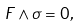Convert formula to latex. <formula><loc_0><loc_0><loc_500><loc_500>F \wedge \sigma = 0 ,</formula> 